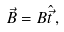Convert formula to latex. <formula><loc_0><loc_0><loc_500><loc_500>\vec { B } = B \hat { \vec { t } } \, ,</formula> 